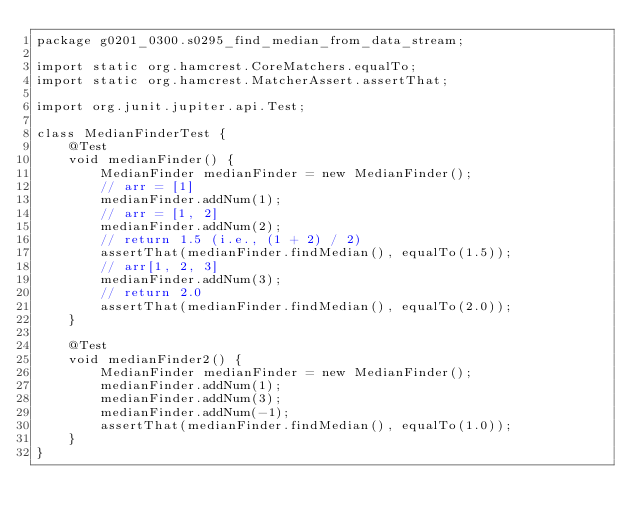Convert code to text. <code><loc_0><loc_0><loc_500><loc_500><_Java_>package g0201_0300.s0295_find_median_from_data_stream;

import static org.hamcrest.CoreMatchers.equalTo;
import static org.hamcrest.MatcherAssert.assertThat;

import org.junit.jupiter.api.Test;

class MedianFinderTest {
    @Test
    void medianFinder() {
        MedianFinder medianFinder = new MedianFinder();
        // arr = [1]
        medianFinder.addNum(1);
        // arr = [1, 2]
        medianFinder.addNum(2);
        // return 1.5 (i.e., (1 + 2) / 2)
        assertThat(medianFinder.findMedian(), equalTo(1.5));
        // arr[1, 2, 3]
        medianFinder.addNum(3);
        // return 2.0
        assertThat(medianFinder.findMedian(), equalTo(2.0));
    }

    @Test
    void medianFinder2() {
        MedianFinder medianFinder = new MedianFinder();
        medianFinder.addNum(1);
        medianFinder.addNum(3);
        medianFinder.addNum(-1);
        assertThat(medianFinder.findMedian(), equalTo(1.0));
    }
}
</code> 